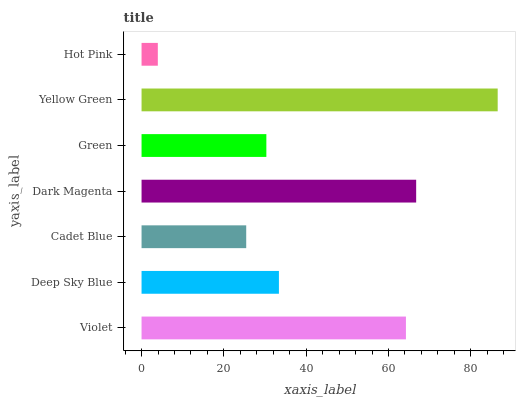Is Hot Pink the minimum?
Answer yes or no. Yes. Is Yellow Green the maximum?
Answer yes or no. Yes. Is Deep Sky Blue the minimum?
Answer yes or no. No. Is Deep Sky Blue the maximum?
Answer yes or no. No. Is Violet greater than Deep Sky Blue?
Answer yes or no. Yes. Is Deep Sky Blue less than Violet?
Answer yes or no. Yes. Is Deep Sky Blue greater than Violet?
Answer yes or no. No. Is Violet less than Deep Sky Blue?
Answer yes or no. No. Is Deep Sky Blue the high median?
Answer yes or no. Yes. Is Deep Sky Blue the low median?
Answer yes or no. Yes. Is Yellow Green the high median?
Answer yes or no. No. Is Cadet Blue the low median?
Answer yes or no. No. 